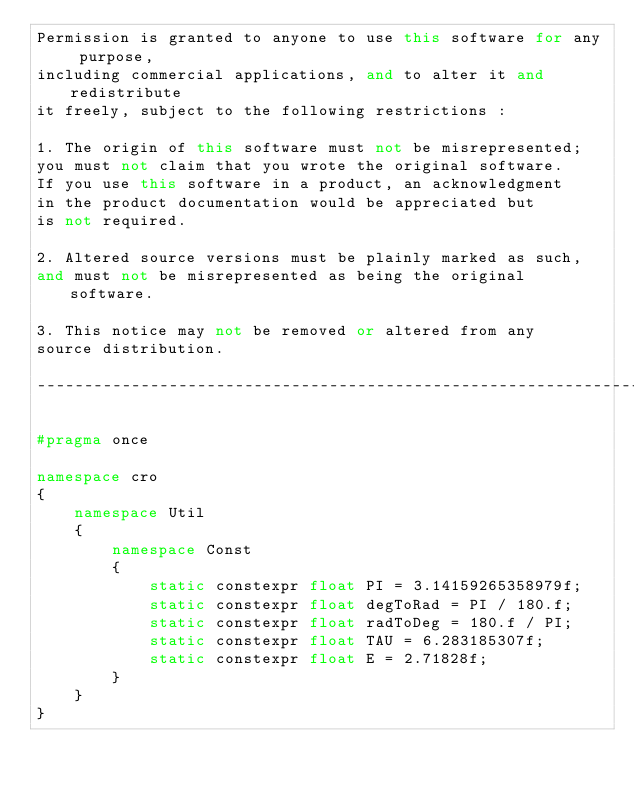<code> <loc_0><loc_0><loc_500><loc_500><_C++_>Permission is granted to anyone to use this software for any purpose,
including commercial applications, and to alter it and redistribute
it freely, subject to the following restrictions :

1. The origin of this software must not be misrepresented;
you must not claim that you wrote the original software.
If you use this software in a product, an acknowledgment
in the product documentation would be appreciated but
is not required.

2. Altered source versions must be plainly marked as such,
and must not be misrepresented as being the original software.

3. This notice may not be removed or altered from any
source distribution.

-----------------------------------------------------------------------*/

#pragma once

namespace cro
{
    namespace Util
    {
        namespace Const
        {
            static constexpr float PI = 3.14159265358979f;
            static constexpr float degToRad = PI / 180.f;
            static constexpr float radToDeg = 180.f / PI;
            static constexpr float TAU = 6.283185307f;
            static constexpr float E = 2.71828f;
        }
    }
}</code> 